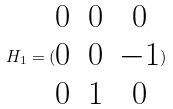Convert formula to latex. <formula><loc_0><loc_0><loc_500><loc_500>H _ { 1 } = ( \begin{matrix} 0 & 0 & 0 \\ 0 & 0 & - 1 \\ 0 & 1 & 0 \end{matrix} )</formula> 